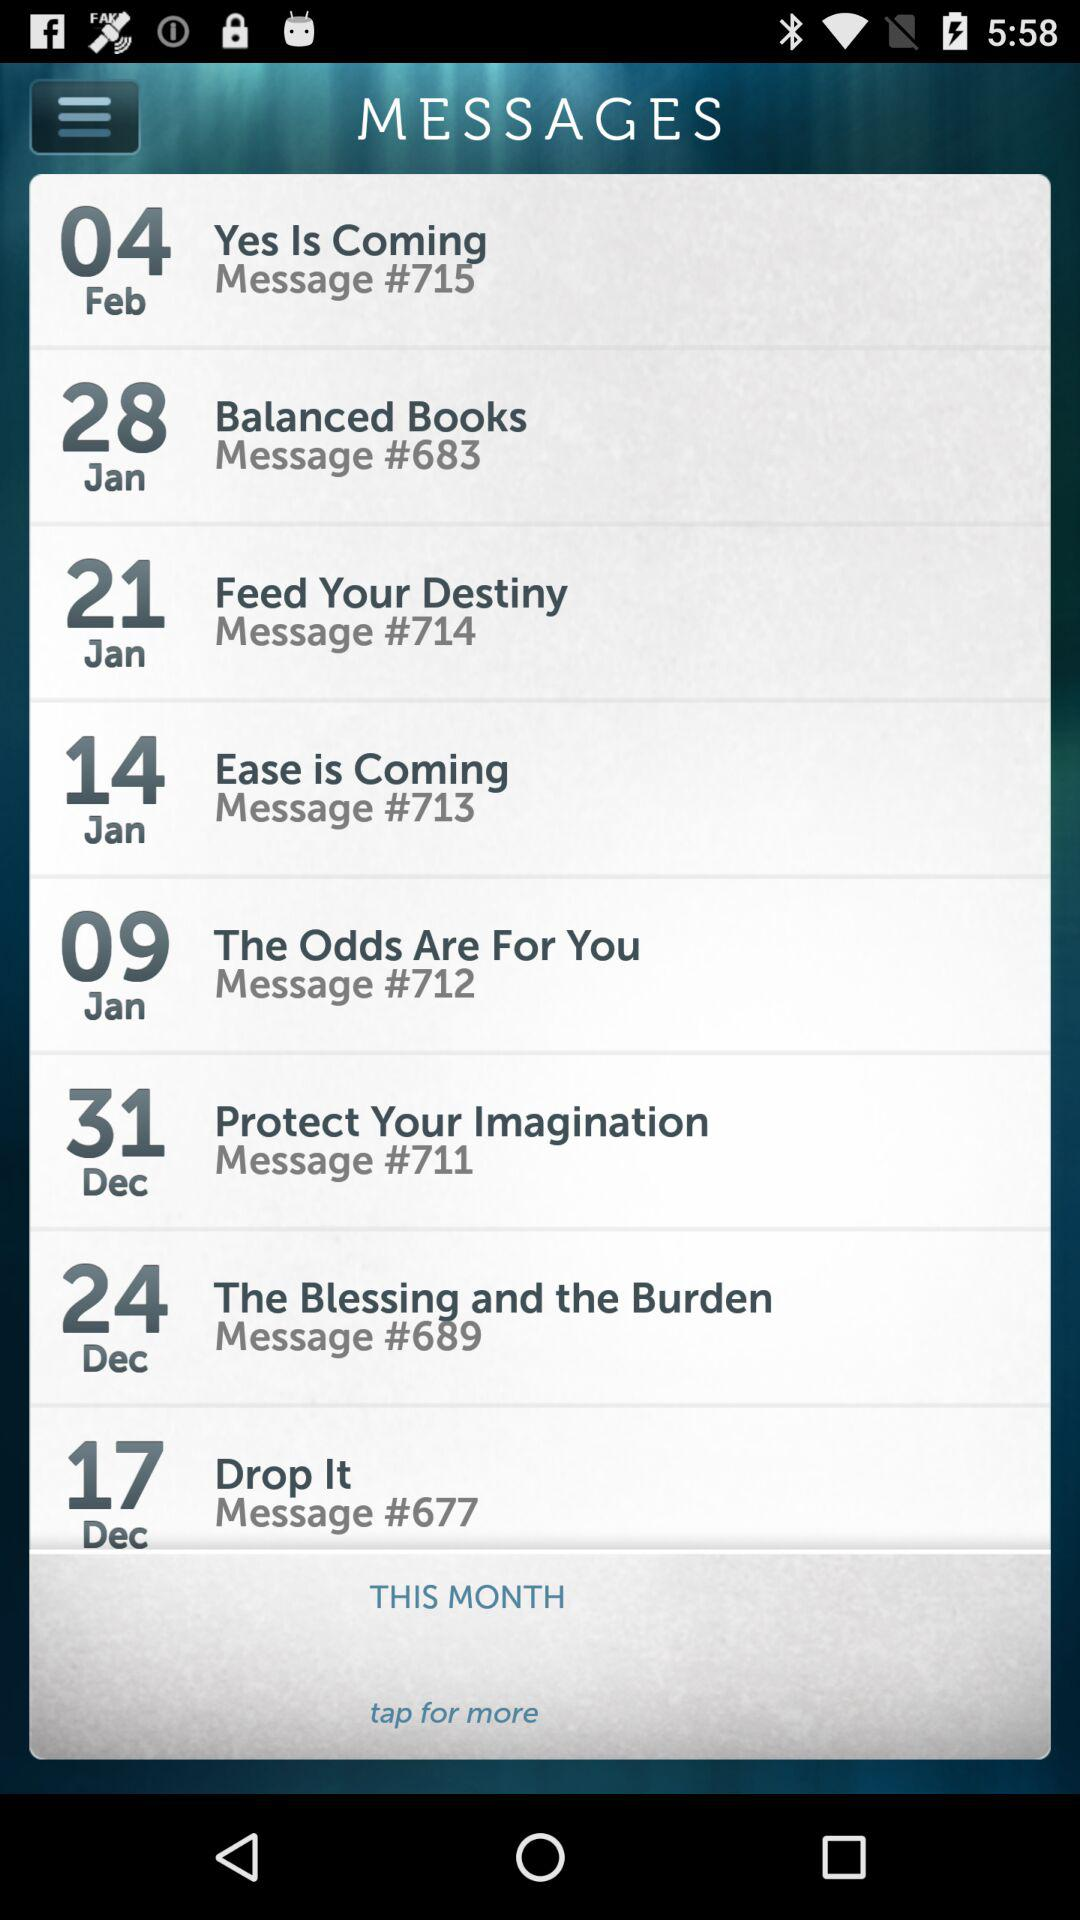What message is shown for Dec. 31? The shown message is "Protect Your Imagination". 